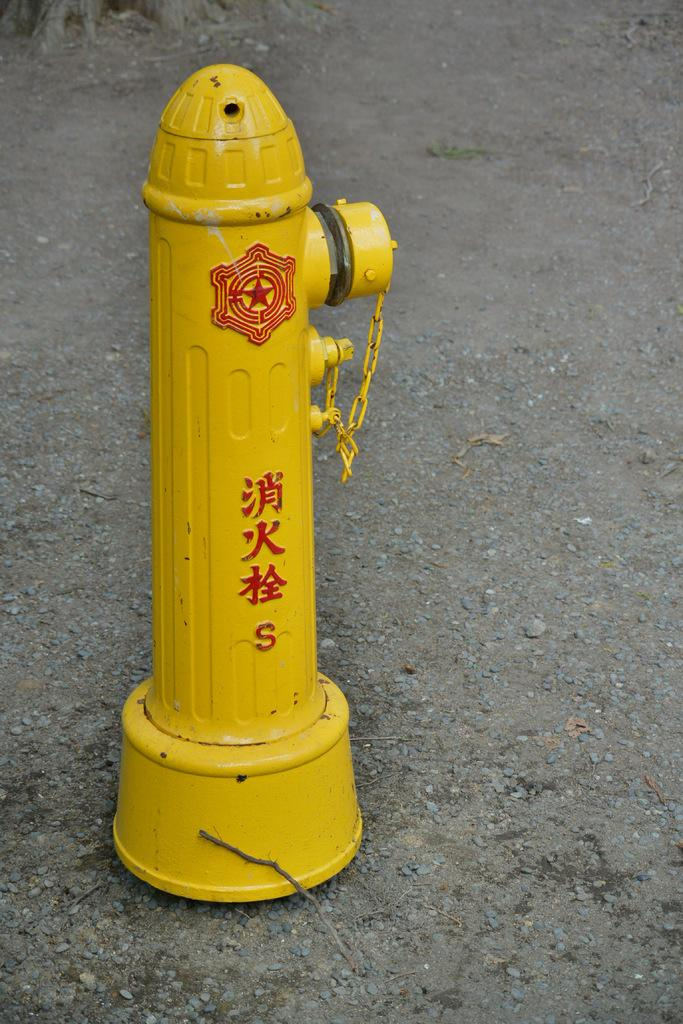What object is the main subject of the image? There is a hydrant in the image. What can be seen on the path in the image? There is a chain and stones on the path in the image. Can you tell me how many people are swimming in the image? There is no swimming or people present in the image; it features a hydrant and a path with a chain and stones. 